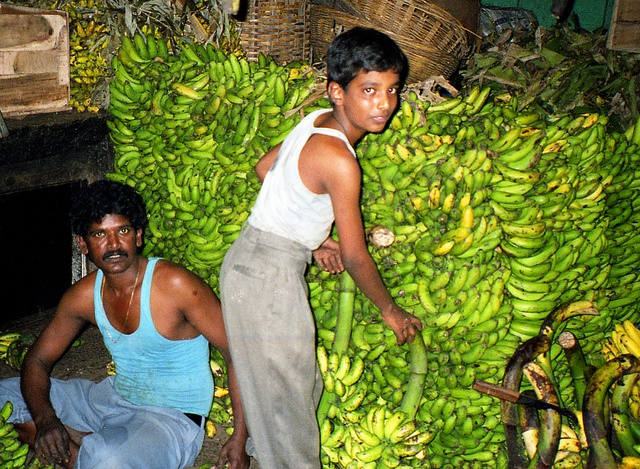Describe the objects in this image and their specific colors. I can see banana in black, darkgreen, and olive tones, people in black, darkgray, white, and salmon tones, people in black, gray, maroon, and lightblue tones, banana in black, olive, and khaki tones, and banana in black, olive, and darkgreen tones in this image. 